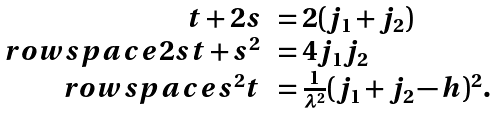<formula> <loc_0><loc_0><loc_500><loc_500>\begin{array} { r l } t + 2 s & = 2 ( j _ { 1 } + j _ { 2 } ) \\ \ r o w s p a c e 2 s t + s ^ { 2 } & = 4 j _ { 1 } j _ { 2 } \\ \ r o w s p a c e s ^ { 2 } t & = \frac { 1 } { { \lambda } ^ { 2 } } ( j _ { 1 } + j _ { 2 } - h ) ^ { 2 } . \end{array}</formula> 